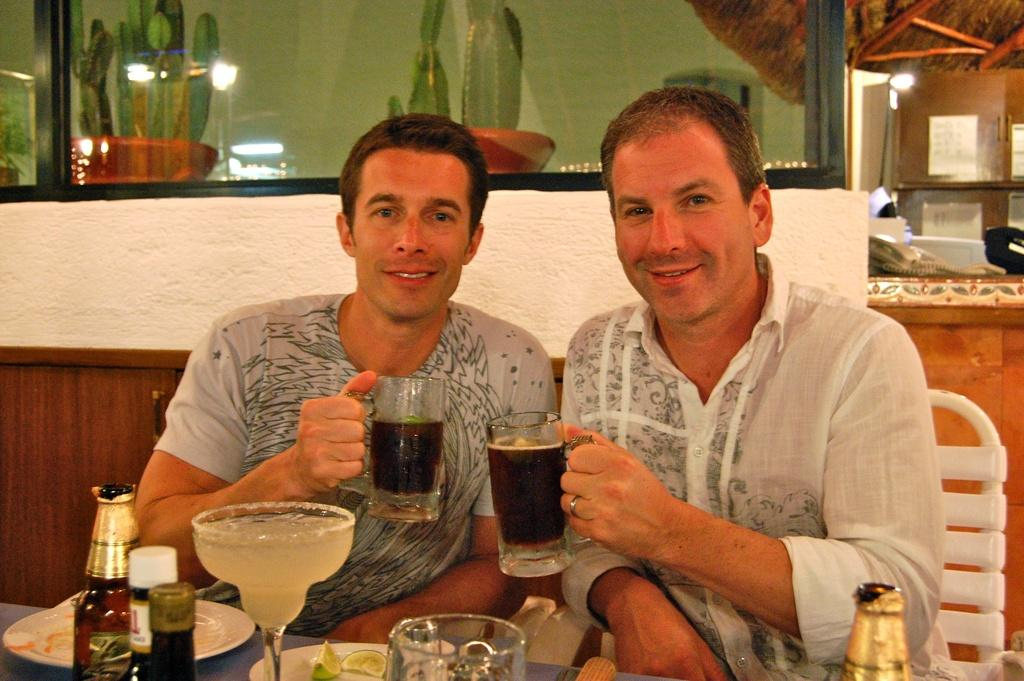How many people are in the image? There are two persons in the image. What are the two persons doing? The two persons are clinking glasses. What else can be seen in the image besides the people? There is a bottle, a glass, and a window in the image. What type of cheese is being served in the basket in the image? There is no basket or cheese present in the image. What is the quill used for in the image? There is no quill present in the image. 